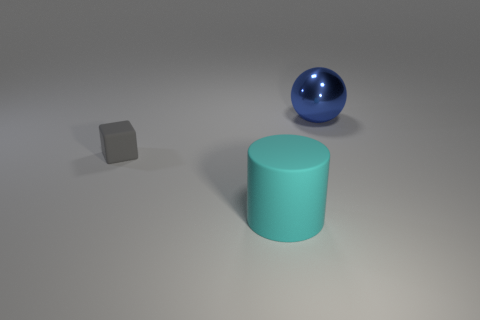Add 2 brown rubber cylinders. How many objects exist? 5 Subtract all spheres. How many objects are left? 2 Subtract 0 yellow cylinders. How many objects are left? 3 Subtract all big metal things. Subtract all cyan matte things. How many objects are left? 1 Add 3 large cyan rubber cylinders. How many large cyan rubber cylinders are left? 4 Add 1 gray matte things. How many gray matte things exist? 2 